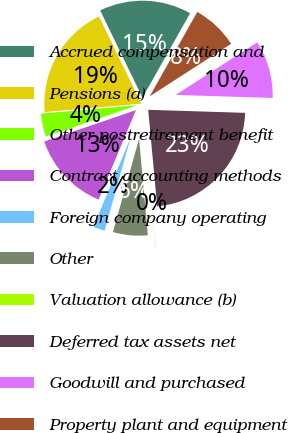Convert chart to OTSL. <chart><loc_0><loc_0><loc_500><loc_500><pie_chart><fcel>Accrued compensation and<fcel>Pensions (a)<fcel>Other postretirement benefit<fcel>Contract accounting methods<fcel>Foreign company operating<fcel>Other<fcel>Valuation allowance (b)<fcel>Deferred tax assets net<fcel>Goodwill and purchased<fcel>Property plant and equipment<nl><fcel>15.36%<fcel>19.2%<fcel>3.87%<fcel>13.45%<fcel>1.95%<fcel>5.78%<fcel>0.04%<fcel>23.03%<fcel>9.62%<fcel>7.7%<nl></chart> 